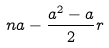<formula> <loc_0><loc_0><loc_500><loc_500>n a - \frac { a ^ { 2 } - a } { 2 } r</formula> 